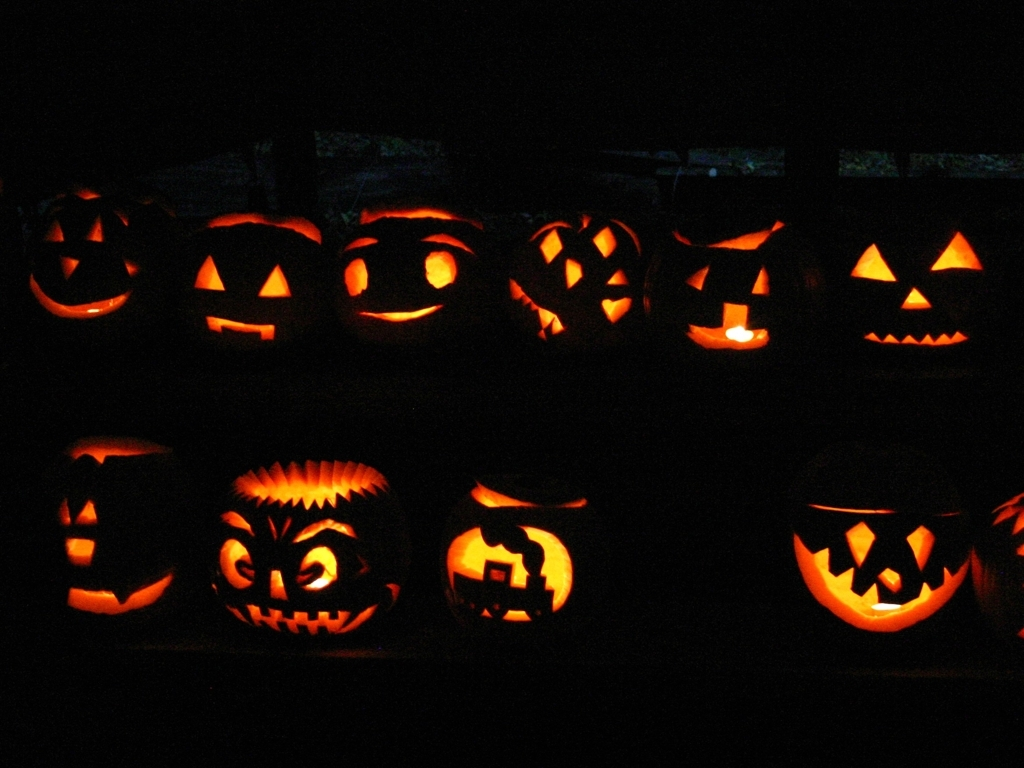Are there any quality issues with this image? The image shows a row of carved jack-o'-lanterns illuminated from within. There is a lack of sharpness which affects the overall clarity, and the photo suffers from underexposure, making the details difficult to see, especially in the shadows. 